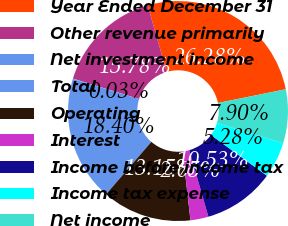<chart> <loc_0><loc_0><loc_500><loc_500><pie_chart><fcel>Year Ended December 31<fcel>Other revenue primarily<fcel>Net investment income<fcel>Total<fcel>Operating<fcel>Interest<fcel>Income before income tax<fcel>Income tax expense<fcel>Net income<nl><fcel>26.28%<fcel>15.78%<fcel>0.03%<fcel>18.4%<fcel>13.15%<fcel>2.65%<fcel>10.53%<fcel>5.28%<fcel>7.9%<nl></chart> 